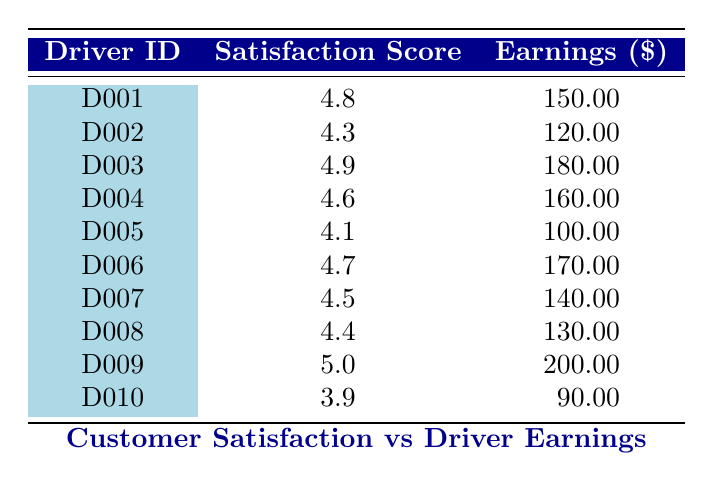What is the customer satisfaction score of driver D006? The table lists the customer satisfaction scores for each driver. For driver D006, the score is explicitly presented as 4.7.
Answer: 4.7 Which driver has the highest earnings, and what is that amount? To find the driver with the highest earnings, I compare the earnings across all drivers. D009 has the highest earnings listed as 200.00.
Answer: D009, 200.00 What is the average customer satisfaction score across all drivers? To calculate the average, sum all the customer satisfaction scores (4.8 + 4.3 + 4.9 + 4.6 + 4.1 + 4.7 + 4.5 + 4.4 + 5.0 + 3.9 = 48.2) and divide by the number of drivers (10). Therefore, the average score is 48.2/10 = 4.82.
Answer: 4.82 Is it true that all drivers with a customer satisfaction score above 4.5 have earnings of over 150.00? Looking at the table, drivers D001 (4.8, 150.00), D003 (4.9, 180.00), D004 (4.6, 160.00), D006 (4.7, 170.00), and D009 (5.0, 200.00) have scores above 4.5. Only D001 has earnings of 150.00, while the others exceed this amount. Therefore, it is false because not all of them exceed 150.00.
Answer: No What is the difference in customer satisfaction score between the highest (D009) and lowest (D010) scoring drivers? The highest score is from D009 which is 5.0 and the lowest score is from D010 which is 3.9. The difference is calculated as 5.0 - 3.9 = 1.1.
Answer: 1.1 What is the total earnings of drivers with a satisfaction score below 4.5? The drivers with a satisfaction score below 4.5 are D002 (120.00), D005 (100.00), D010 (90.00), and their respective earnings are summed (120.00 + 100.00 + 90.00 = 310.00).
Answer: 310.00 Which driver has the closest customer satisfaction score to the average score? The average score calculated was 4.82. Comparing each driver’s score to 4.82, D004 (4.6) and D006 (4.7) are the closest, but D006 with a score of 4.7 is nearer to the average.
Answer: D006 Do all drivers have customer satisfaction scores that are above 4.0? Checking each driver, D010 has a score of 3.9, which is below 4.0. Therefore, it is false that all drivers have scores above 4.0.
Answer: No 